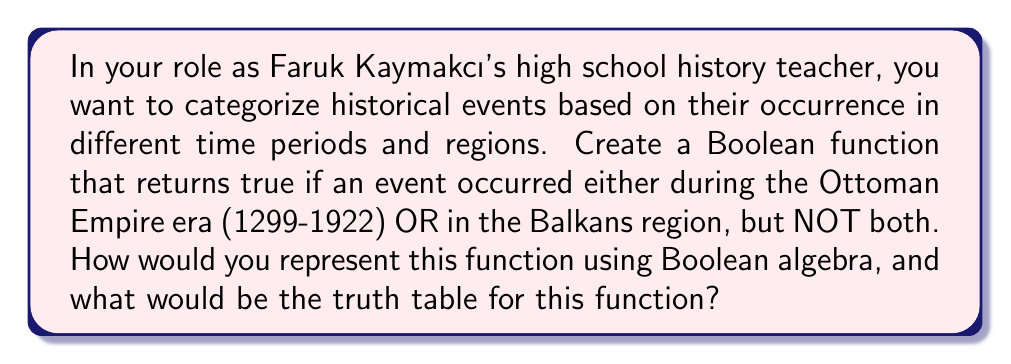Teach me how to tackle this problem. Let's approach this step-by-step:

1) First, we need to define our variables:
   Let $A$ = event occurred during the Ottoman Empire era (1299-1922)
   Let $B$ = event occurred in the Balkans region

2) The Boolean function we want is an XOR (exclusive OR) function. In Boolean algebra, this is represented as:

   $$ F = A \oplus B $$

   This can also be written as:

   $$ F = (A \lor B) \land (\lnot(A \land B)) $$

3) To create the truth table, we need to consider all possible combinations of A and B:

   | A | B | F |
   |---|---|---|
   | 0 | 0 | 0 |
   | 0 | 1 | 1 |
   | 1 | 0 | 1 |
   | 1 | 1 | 0 |

4) Explanation of the truth table:
   - If neither condition is true (A = 0, B = 0), the function returns false (0).
   - If only one condition is true (A = 0, B = 1 or A = 1, B = 0), the function returns true (1).
   - If both conditions are true (A = 1, B = 1), the function returns false (0), as we don't want events that satisfy both conditions.

5) This Boolean function allows us to categorize historical events that occurred either during the Ottoman Empire era OR in the Balkans, but not both, which can be useful for organizing and analyzing historical data in your history class.
Answer: $F = A \oplus B$ 